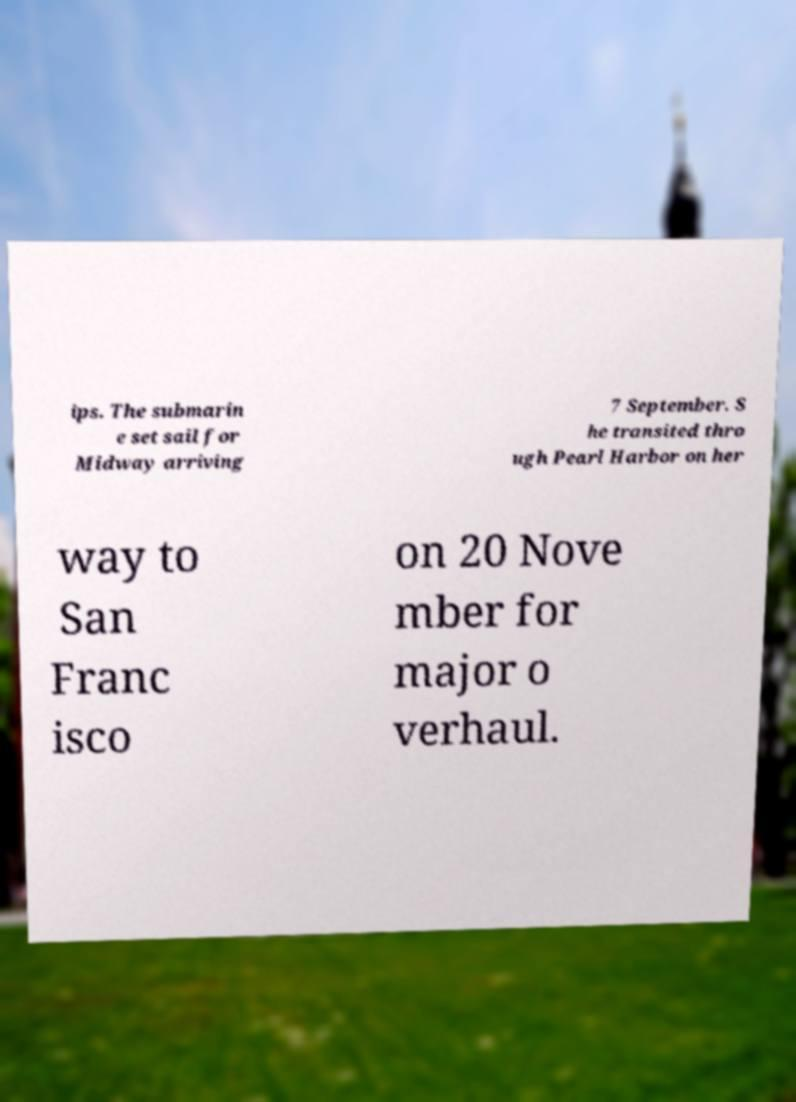There's text embedded in this image that I need extracted. Can you transcribe it verbatim? ips. The submarin e set sail for Midway arriving 7 September. S he transited thro ugh Pearl Harbor on her way to San Franc isco on 20 Nove mber for major o verhaul. 